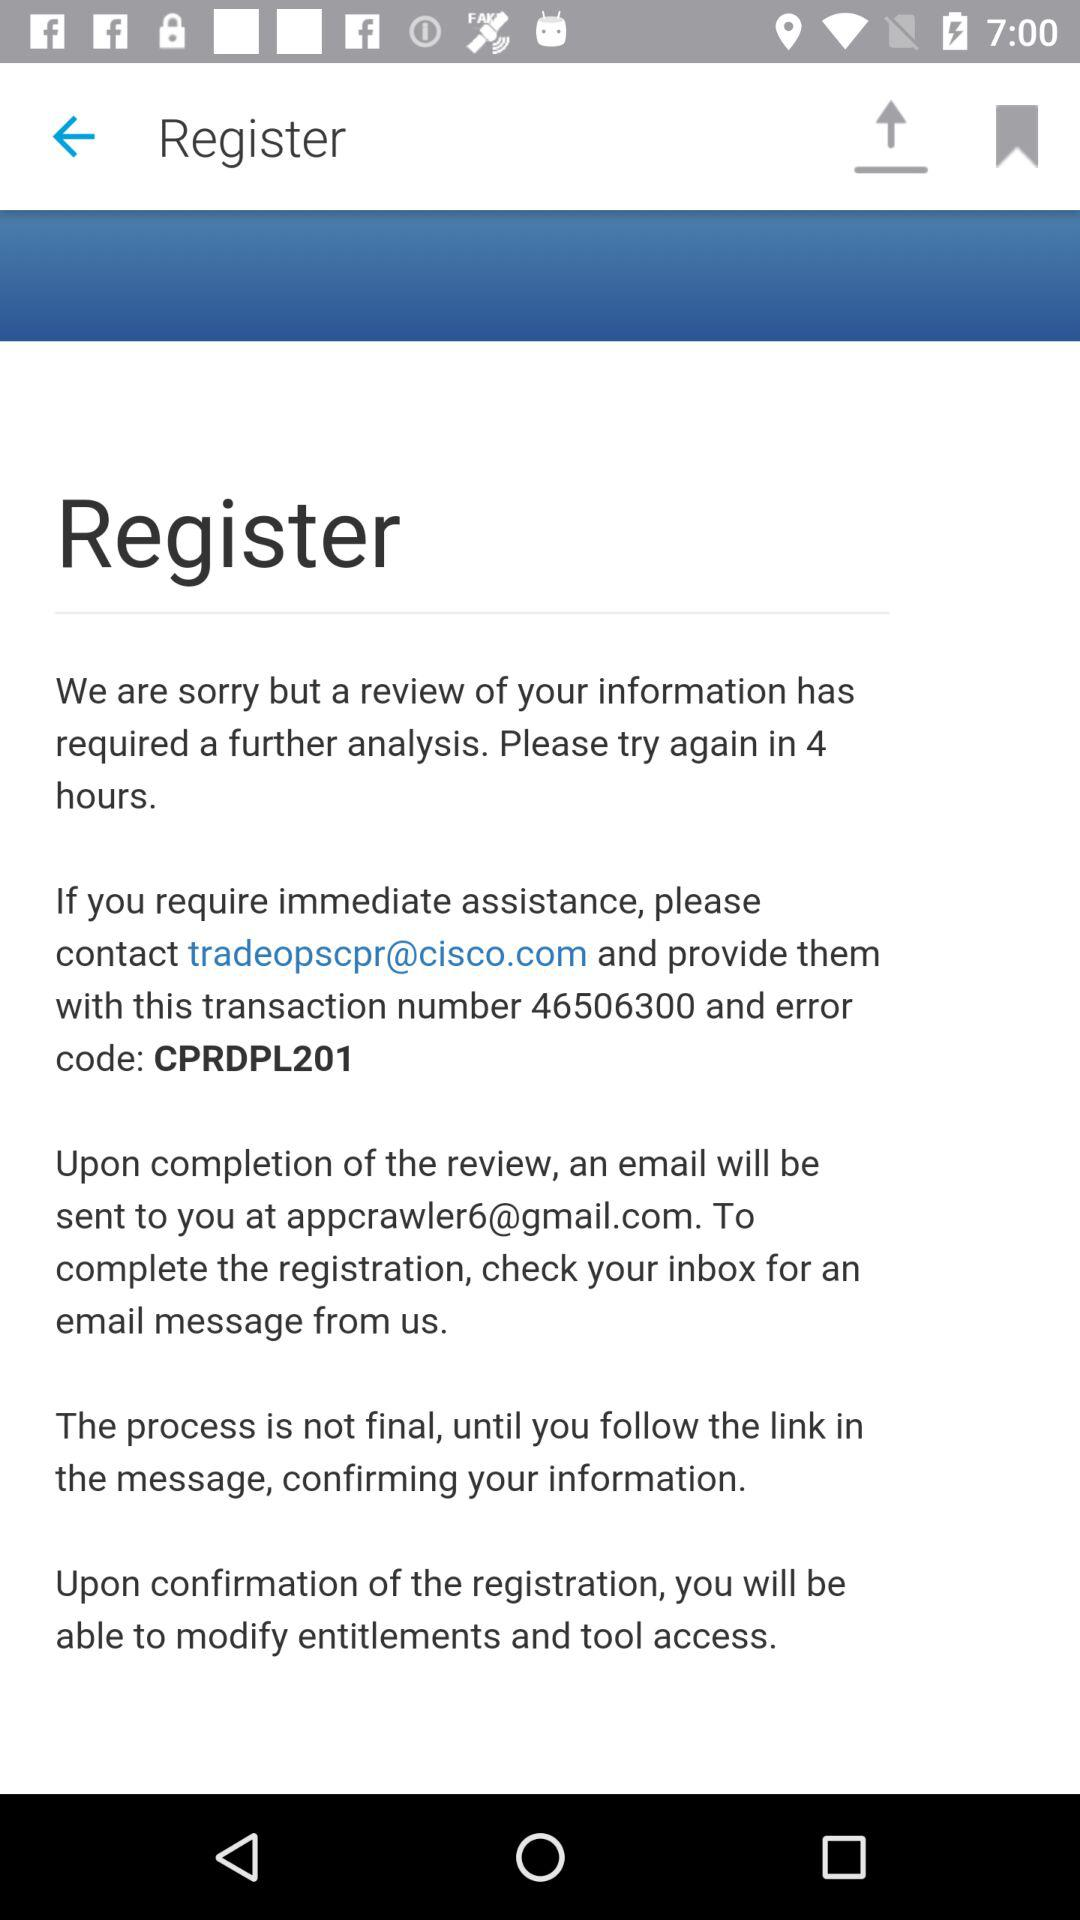Has the email message been received?
When the provided information is insufficient, respond with <no answer>. <no answer> 